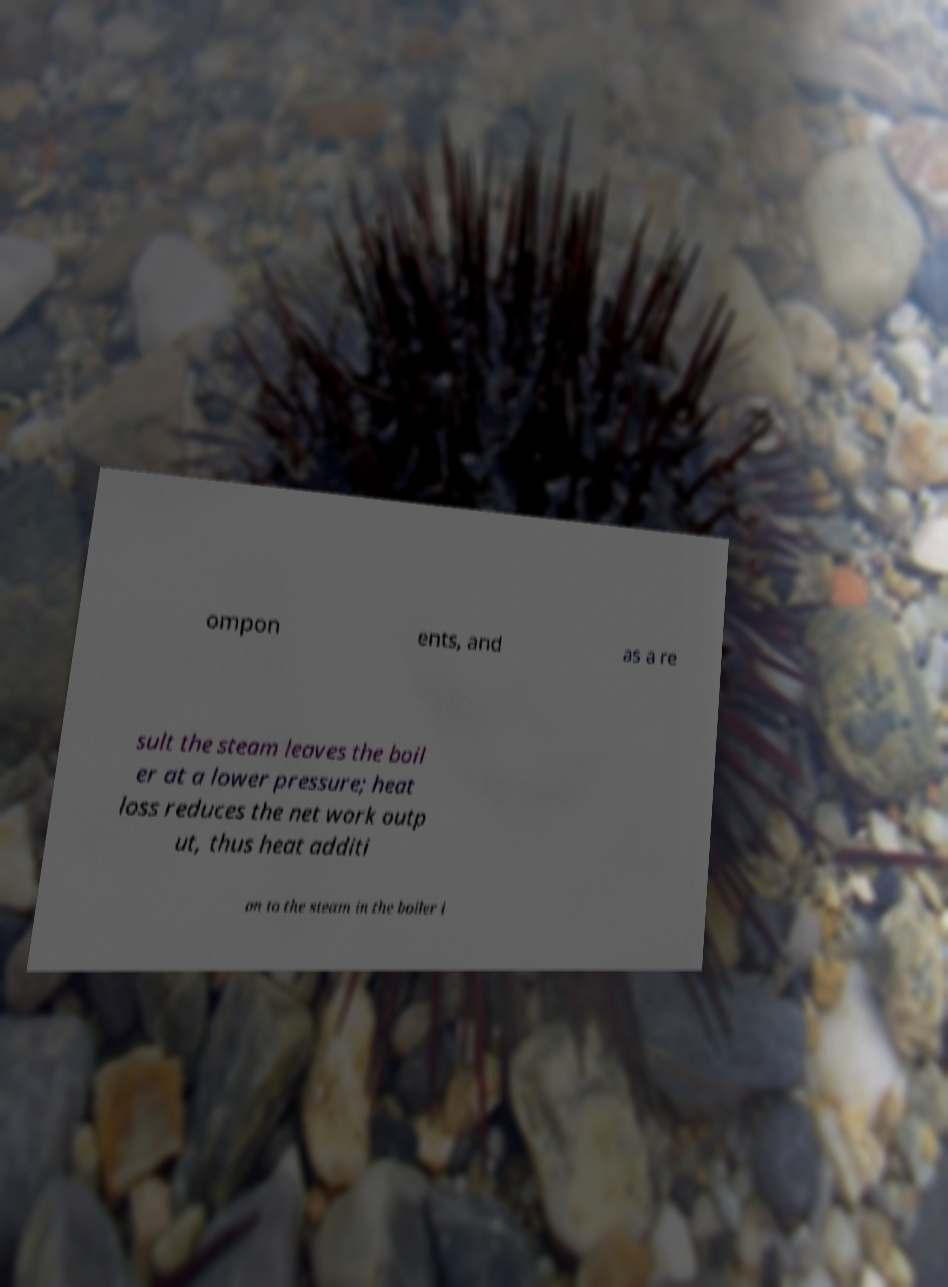For documentation purposes, I need the text within this image transcribed. Could you provide that? ompon ents, and as a re sult the steam leaves the boil er at a lower pressure; heat loss reduces the net work outp ut, thus heat additi on to the steam in the boiler i 